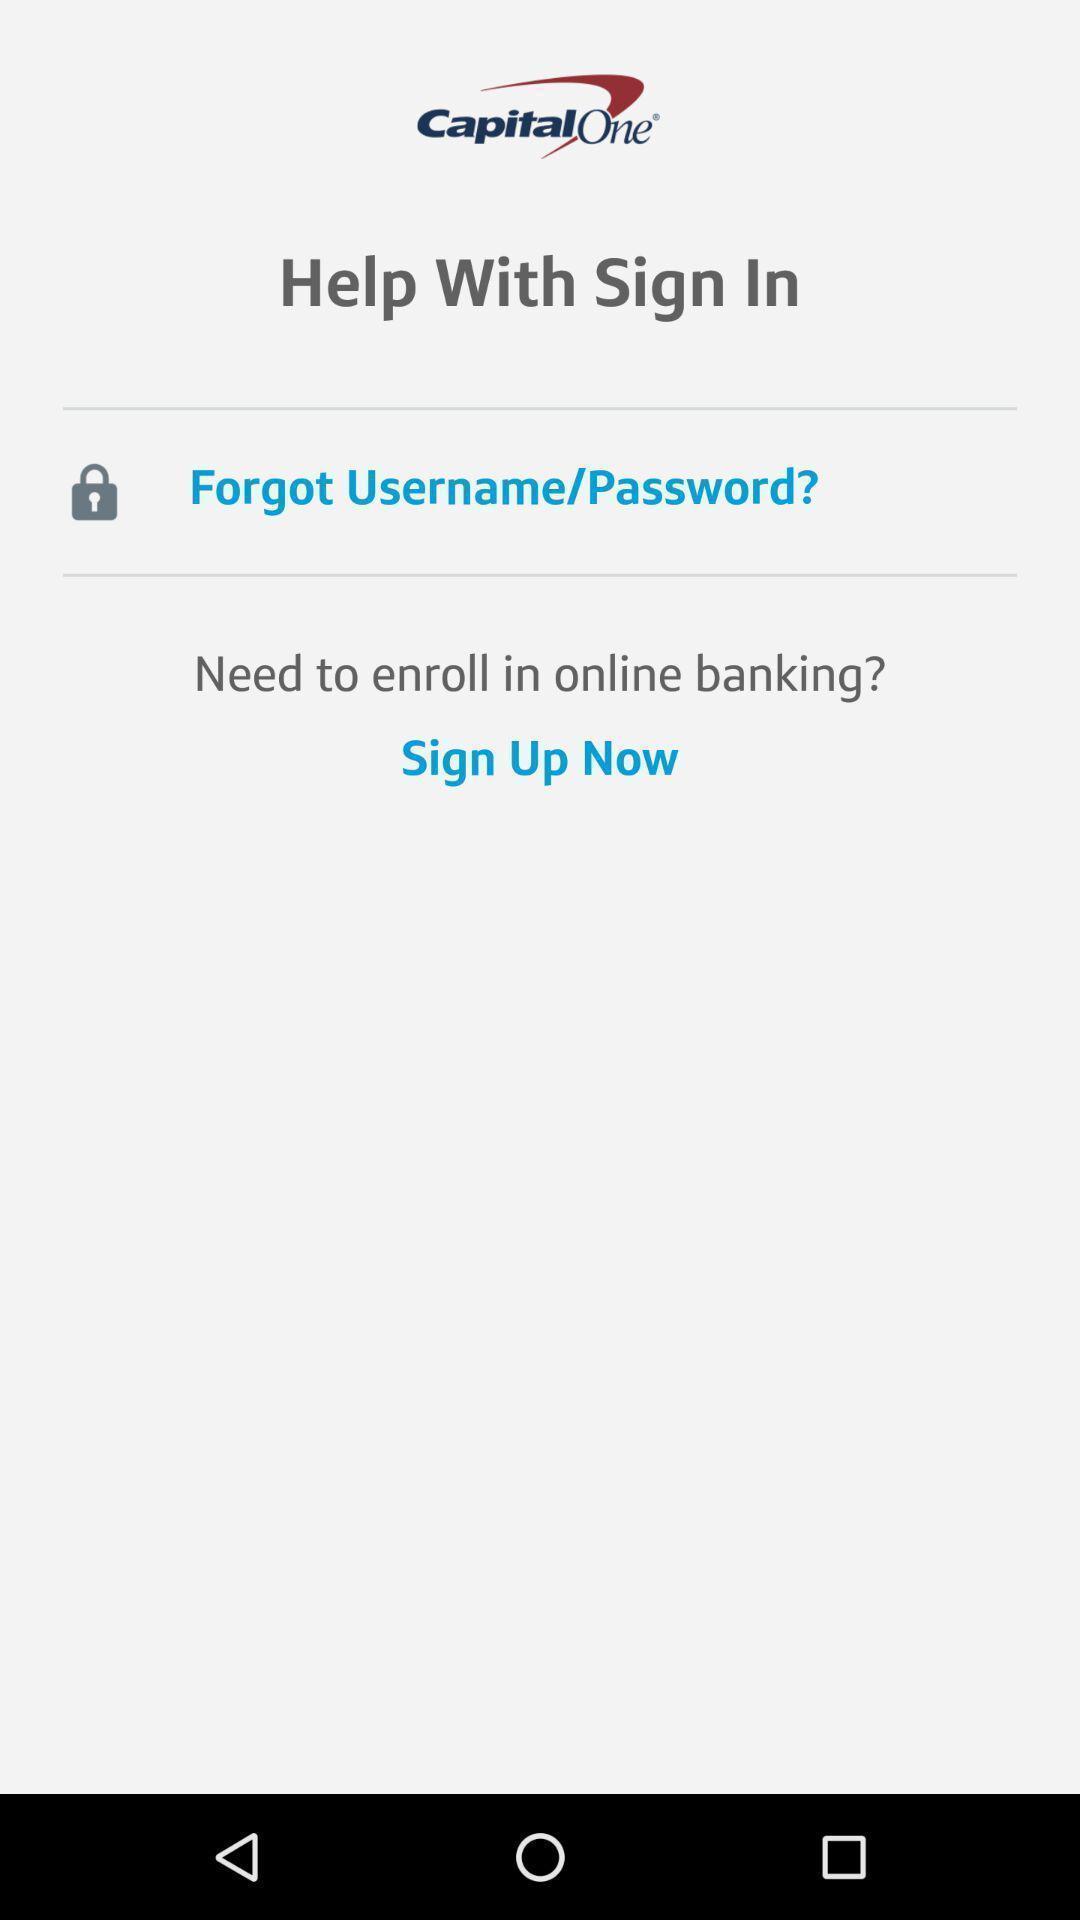What can you discern from this picture? Sign page. 